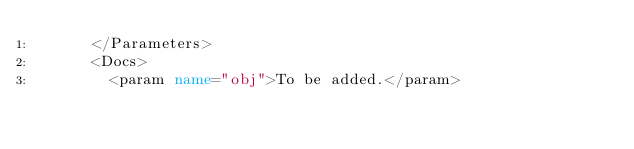Convert code to text. <code><loc_0><loc_0><loc_500><loc_500><_XML_>      </Parameters>
      <Docs>
        <param name="obj">To be added.</param></code> 